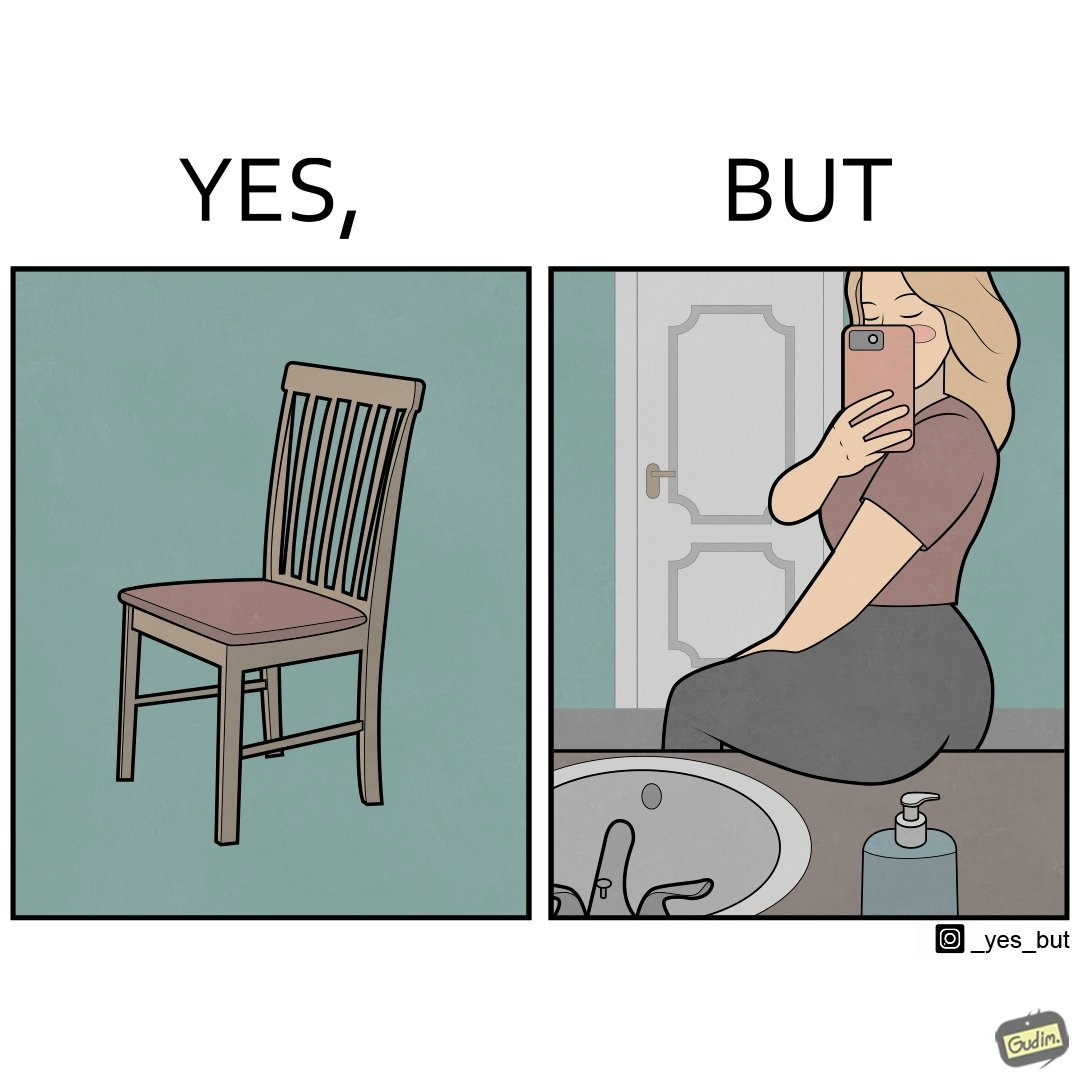What do you see in each half of this image? In the left part of the image: a chair. In the right part of the image: a woman sitting by the sink taking a selfie using a mirror. 